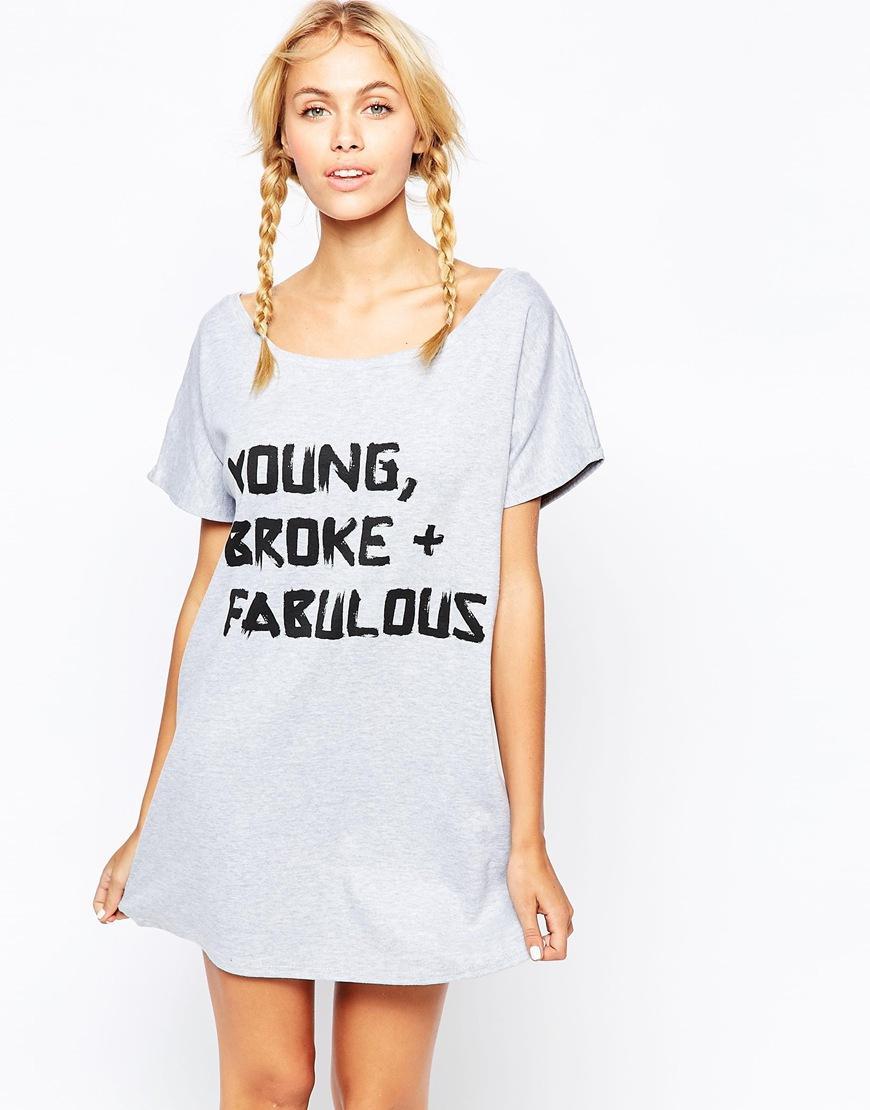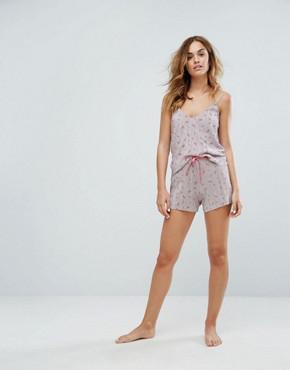The first image is the image on the left, the second image is the image on the right. Examine the images to the left and right. Is the description "In the images, both models wear bottoms that are virtually the same length." accurate? Answer yes or no. No. 